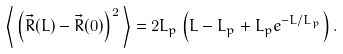<formula> <loc_0><loc_0><loc_500><loc_500>\left \langle \, \left ( \vec { R } ( L ) - \vec { R } ( 0 ) \right ) ^ { 2 } \, \right \rangle = 2 L _ { p } \left ( L - L _ { p } + L _ { p } e ^ { - L / L _ { p } } \right ) .</formula> 